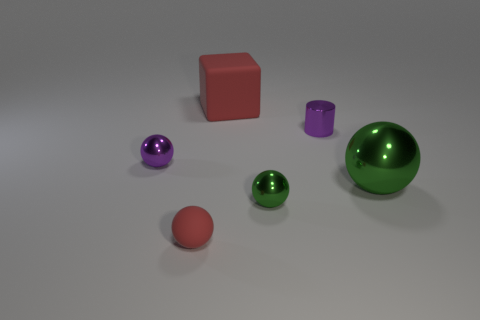What number of matte things are big brown cubes or small purple balls?
Your response must be concise. 0. Are the tiny green object and the large red thing made of the same material?
Your answer should be compact. No. What material is the red object behind the small object on the left side of the tiny rubber thing?
Ensure brevity in your answer.  Rubber. How many small things are either purple things or red things?
Your response must be concise. 3. What is the size of the purple cylinder?
Provide a succinct answer. Small. Are there more red matte blocks that are left of the red rubber cube than large balls?
Make the answer very short. No. Is the number of cylinders that are behind the big red object the same as the number of green things that are in front of the large green sphere?
Keep it short and to the point. No. What color is the object that is both to the left of the large red thing and behind the rubber sphere?
Ensure brevity in your answer.  Purple. Is there anything else that is the same size as the rubber block?
Offer a terse response. Yes. Are there more large metal objects that are behind the large green metallic ball than small cylinders on the right side of the small purple metal cylinder?
Provide a short and direct response. No. 